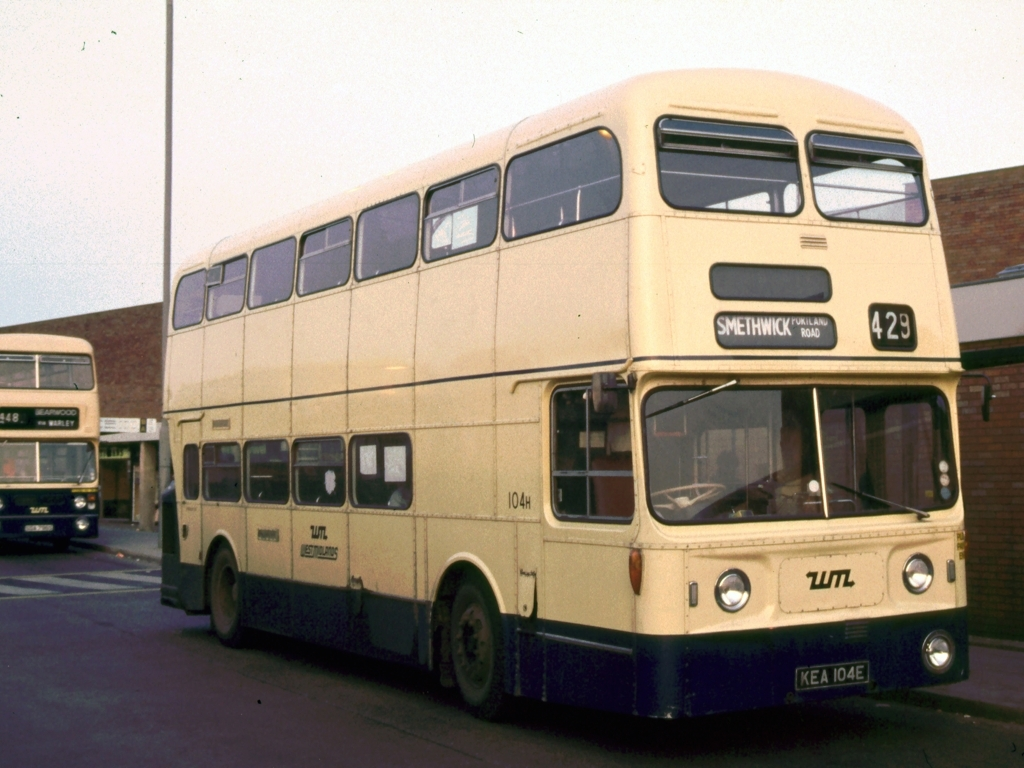Are there any noise points in the image? Based on the image provided, there is no evidence of noise points such as distortions or random speckles that would typically affect the quality of a digital image. The photo appears to be clear with no significant visual noise. 